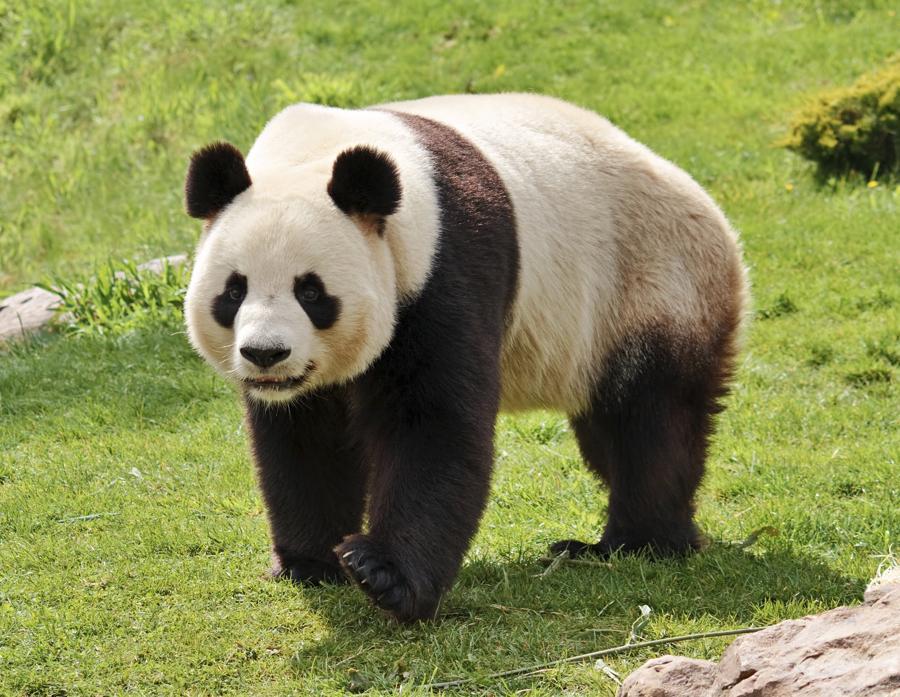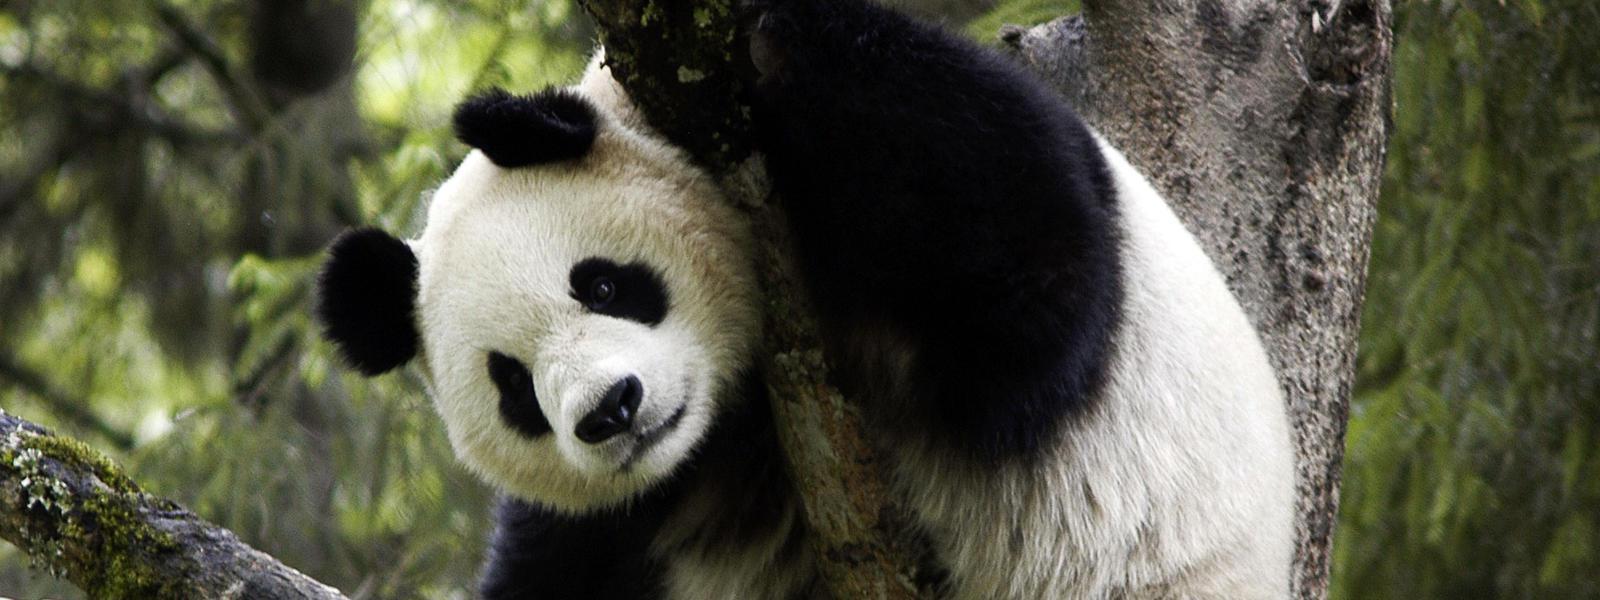The first image is the image on the left, the second image is the image on the right. For the images shown, is this caption "A panda is resting its chin." true? Answer yes or no. No. The first image is the image on the left, the second image is the image on the right. Evaluate the accuracy of this statement regarding the images: "An image includes a panda at least partly on its back on green ground.". Is it true? Answer yes or no. No. 